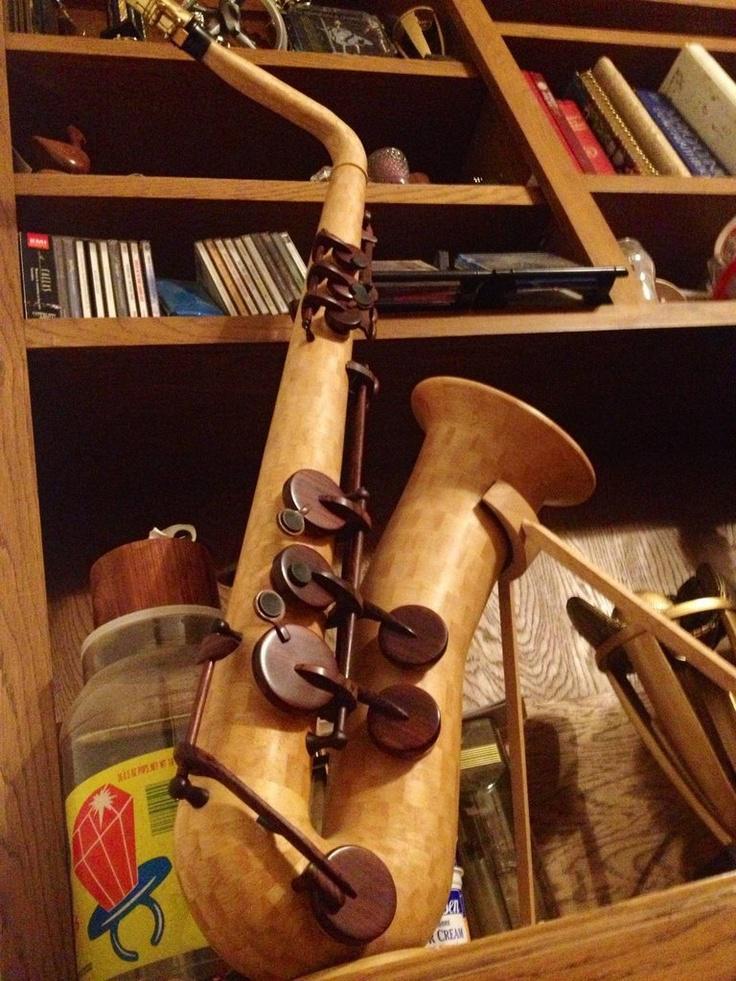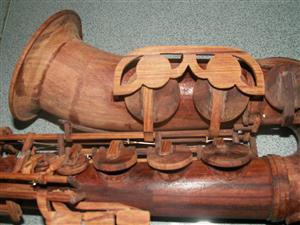The first image is the image on the left, the second image is the image on the right. Evaluate the accuracy of this statement regarding the images: "In one of the images there are two saxophones placed next to each other.". Is it true? Answer yes or no. No. 